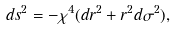<formula> <loc_0><loc_0><loc_500><loc_500>d s ^ { 2 } = - \chi ^ { 4 } ( d r ^ { 2 } + r ^ { 2 } d \sigma ^ { 2 } ) ,</formula> 